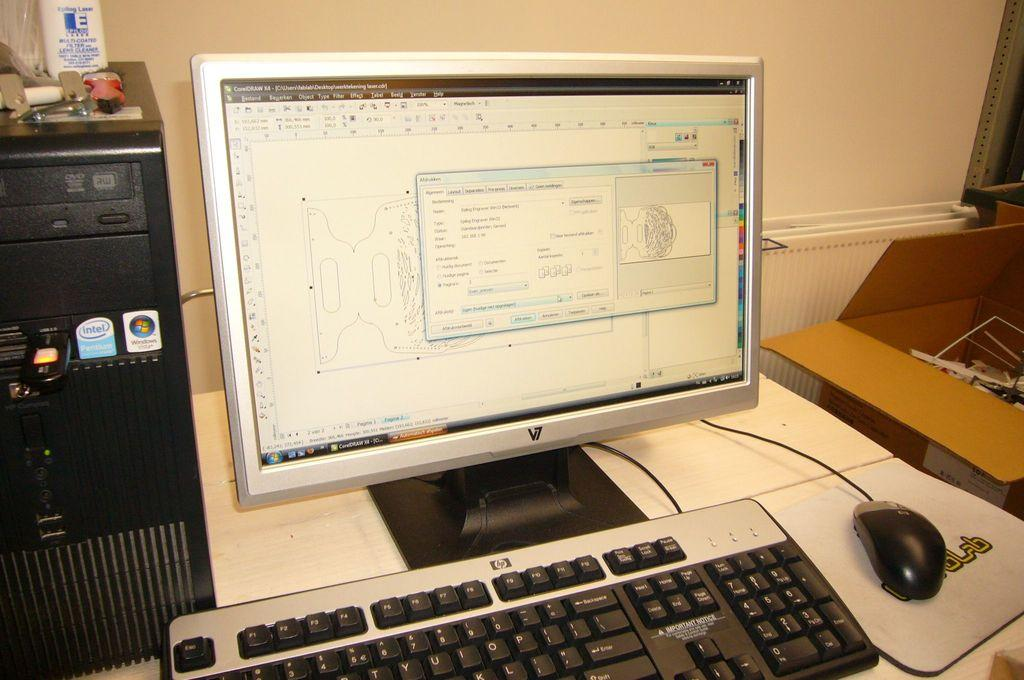<image>
Present a compact description of the photo's key features. A computer sitting on a desk has an HP brand keyboard. 